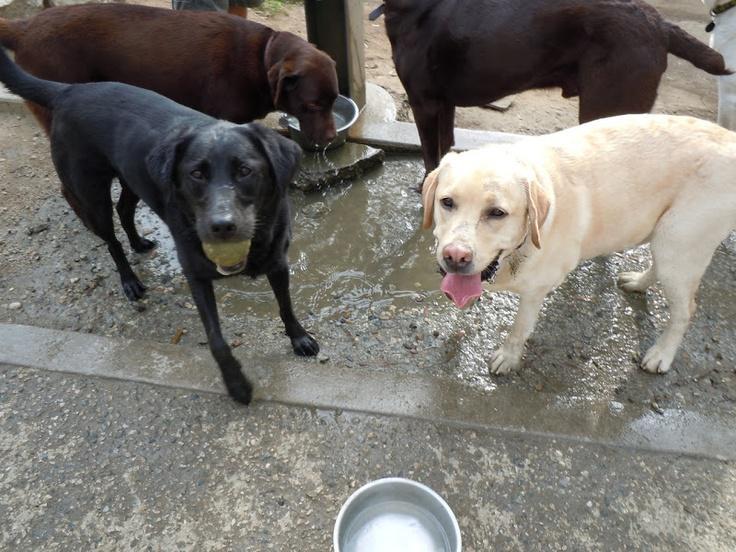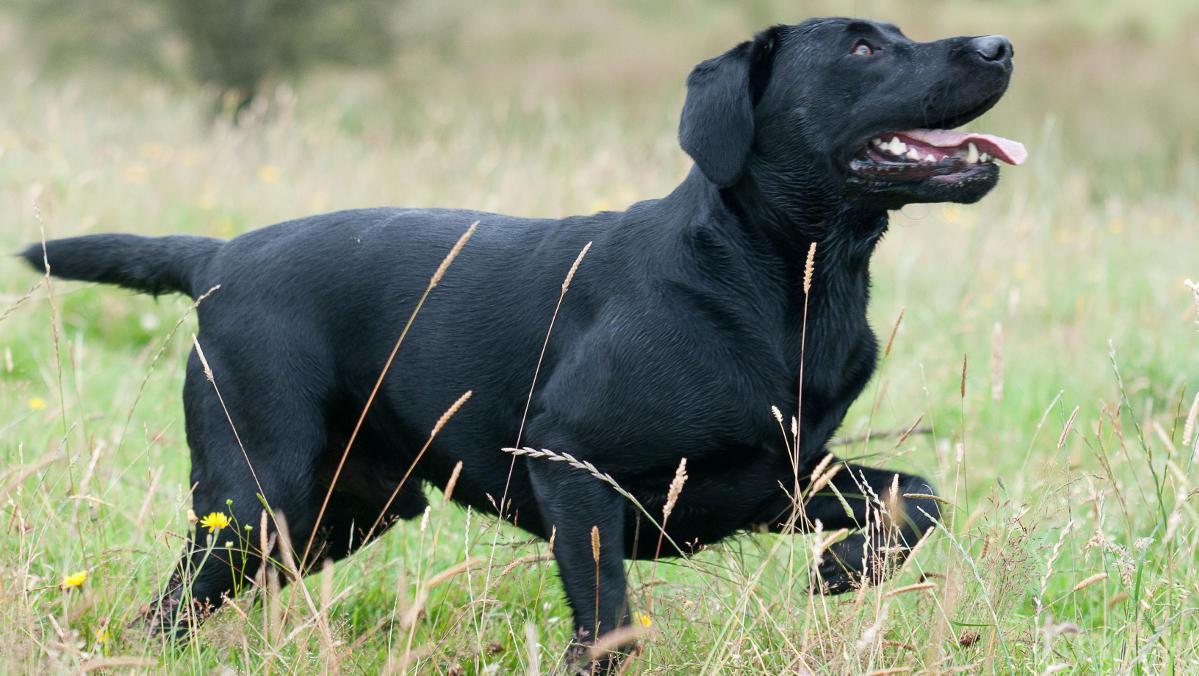The first image is the image on the left, the second image is the image on the right. For the images displayed, is the sentence "Left image shows one dog, which is solid brown and pictured outdoors." factually correct? Answer yes or no. No. The first image is the image on the left, the second image is the image on the right. Assess this claim about the two images: "There are no more than four labradors outside.". Correct or not? Answer yes or no. No. 